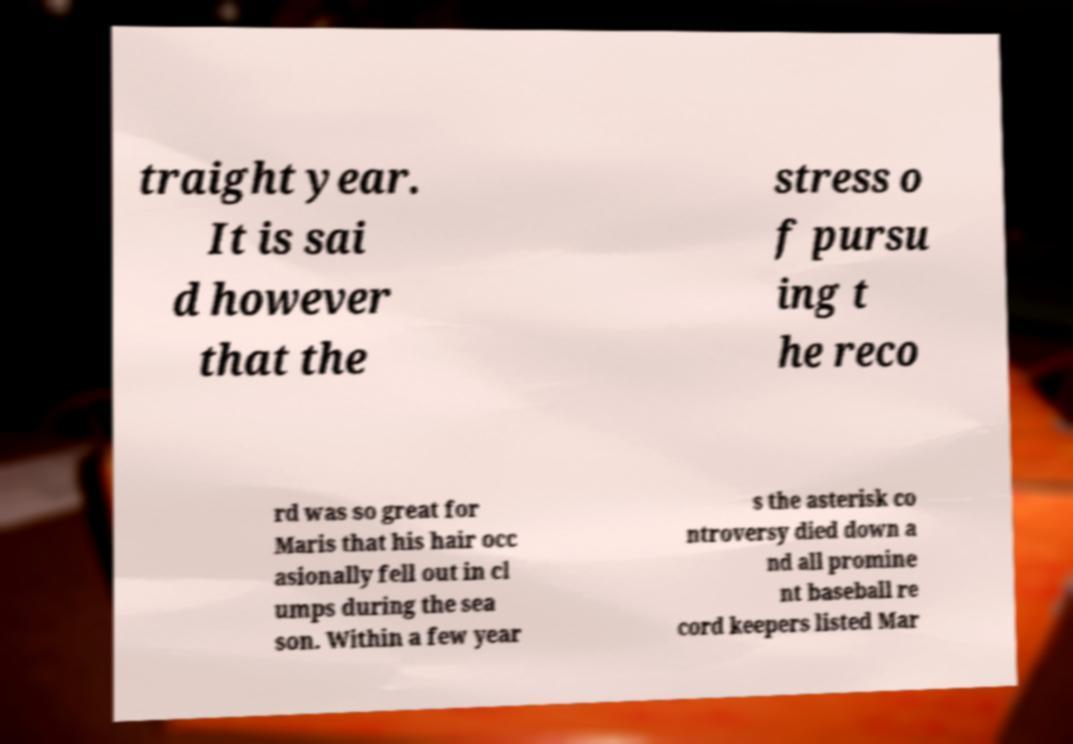Could you extract and type out the text from this image? traight year. It is sai d however that the stress o f pursu ing t he reco rd was so great for Maris that his hair occ asionally fell out in cl umps during the sea son. Within a few year s the asterisk co ntroversy died down a nd all promine nt baseball re cord keepers listed Mar 